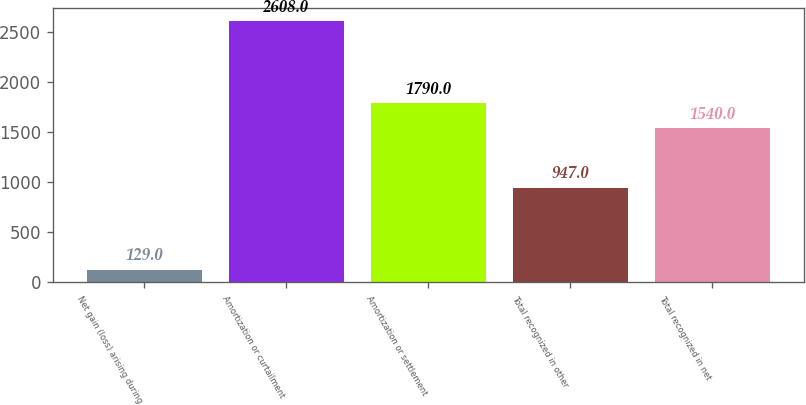<chart> <loc_0><loc_0><loc_500><loc_500><bar_chart><fcel>Net gain (loss) arising during<fcel>Amortization or curtailment<fcel>Amortization or settlement<fcel>Total recognized in other<fcel>Total recognized in net<nl><fcel>129<fcel>2608<fcel>1790<fcel>947<fcel>1540<nl></chart> 